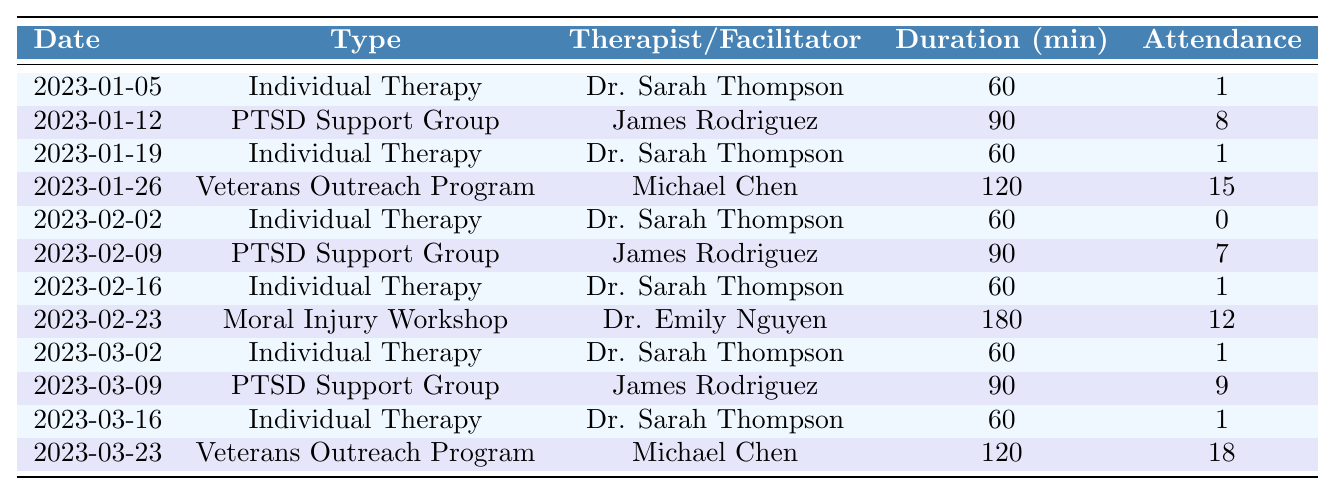What type of therapy was conducted on 2023-01-19? The session on 2023-01-19 is listed under the "Type" column, which shows "Individual Therapy" for that date.
Answer: Individual Therapy Who facilitated the PTSD Support Group on 2023-03-09? The facilitator for the session on 2023-03-09 is indicated in the "Facilitator" column, which states "James Rodriguez."
Answer: James Rodriguez How many attendees were present at the Veterans Outreach Program on 2023-01-26? The number of attendees can be found in the "Attendance" column for the date 2023-01-26, which shows the value "15."
Answer: 15 What was the total attendance for all Individual Therapy sessions? To find the total attendance, sum the attendance of all the Individual Therapy entries: (1 + 1 + 0 + 1 + 1 + 1) = 5.
Answer: 5 Which session had the highest attendance? By comparing the attendance values across all sessions, the maximum is found on 2023-03-23, with "18" attendees for the Veterans Outreach Program.
Answer: 18 Was there a session with no attendance, and if so, which date did it occur? Looking at the "Attendance" column, there is indeed a session with "0" attendance on 2023-02-02.
Answer: Yes, on 2023-02-02 What is the average duration of the Moral Injury Workshop? The duration for this specific session is listed as "180" minutes, and since there's only one entry, the average is also 180 minutes.
Answer: 180 How many different facilitators led sessions in January 2023? In January 2023, there are three facilitators listed: Dr. Sarah Thompson, James Rodriguez, and Michael Chen.
Answer: 3 What was the total attendance across all PTSD Support Group sessions? The attendance for each PTSD Support Group is 8 (2023-01-12) + 7 (2023-02-09) + 9 (2023-03-09) = 24.
Answer: 24 Did the attendance for the Veterans Outreach Program increase from January to March? Comparing the attendance figures, January had 15 and March had 18, indicating an increase.
Answer: Yes 